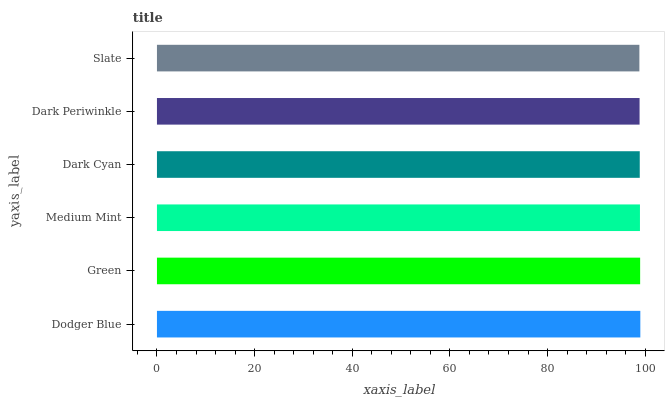Is Slate the minimum?
Answer yes or no. Yes. Is Dodger Blue the maximum?
Answer yes or no. Yes. Is Green the minimum?
Answer yes or no. No. Is Green the maximum?
Answer yes or no. No. Is Dodger Blue greater than Green?
Answer yes or no. Yes. Is Green less than Dodger Blue?
Answer yes or no. Yes. Is Green greater than Dodger Blue?
Answer yes or no. No. Is Dodger Blue less than Green?
Answer yes or no. No. Is Medium Mint the high median?
Answer yes or no. Yes. Is Dark Cyan the low median?
Answer yes or no. Yes. Is Slate the high median?
Answer yes or no. No. Is Dark Periwinkle the low median?
Answer yes or no. No. 